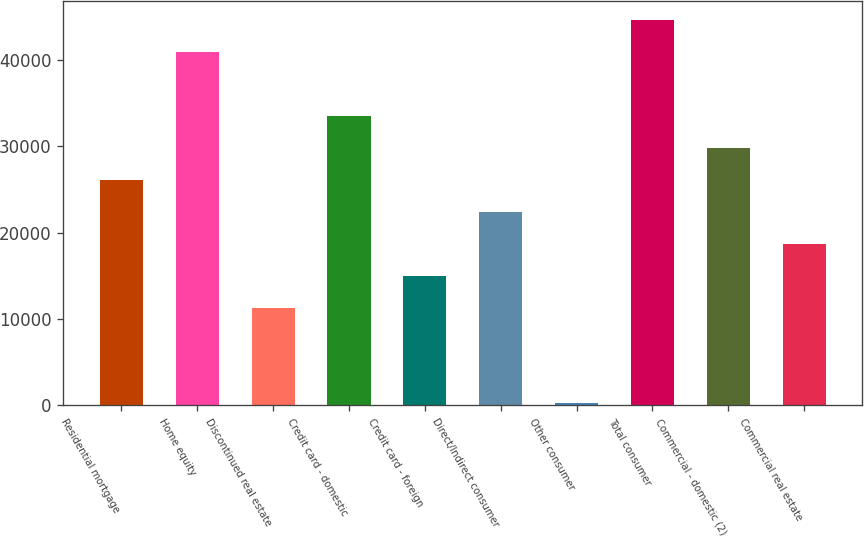Convert chart to OTSL. <chart><loc_0><loc_0><loc_500><loc_500><bar_chart><fcel>Residential mortgage<fcel>Home equity<fcel>Discontinued real estate<fcel>Credit card - domestic<fcel>Credit card - foreign<fcel>Direct/Indirect consumer<fcel>Other consumer<fcel>Total consumer<fcel>Commercial - domestic (2)<fcel>Commercial real estate<nl><fcel>26101.2<fcel>40899.6<fcel>11302.8<fcel>33500.4<fcel>15002.4<fcel>22401.6<fcel>204<fcel>44599.2<fcel>29800.8<fcel>18702<nl></chart> 